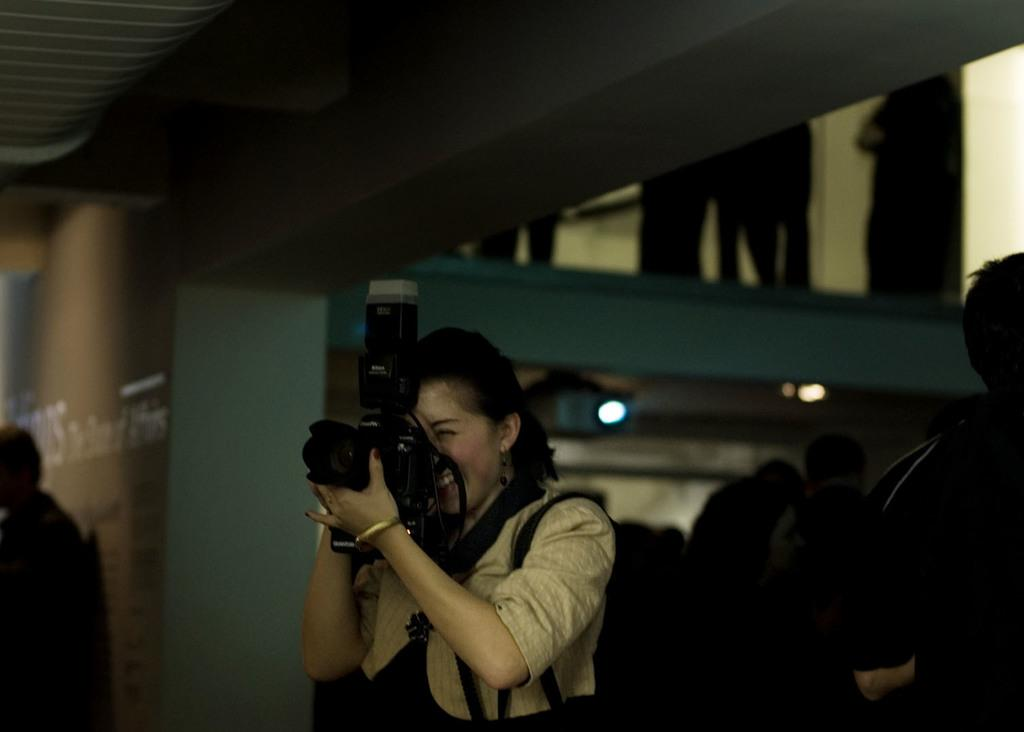Who is the main subject in the image? There is a woman in the image. What is the woman doing in the image? The woman is holding a camera and capturing a picture. What can be seen in the background of the image? There is a crowd, a wall, and lights visible in the background of the image. How many clocks can be seen hanging on the wall in the image? There are no clocks visible in the image; only a crowd, a wall, and lights can be seen in the background. 